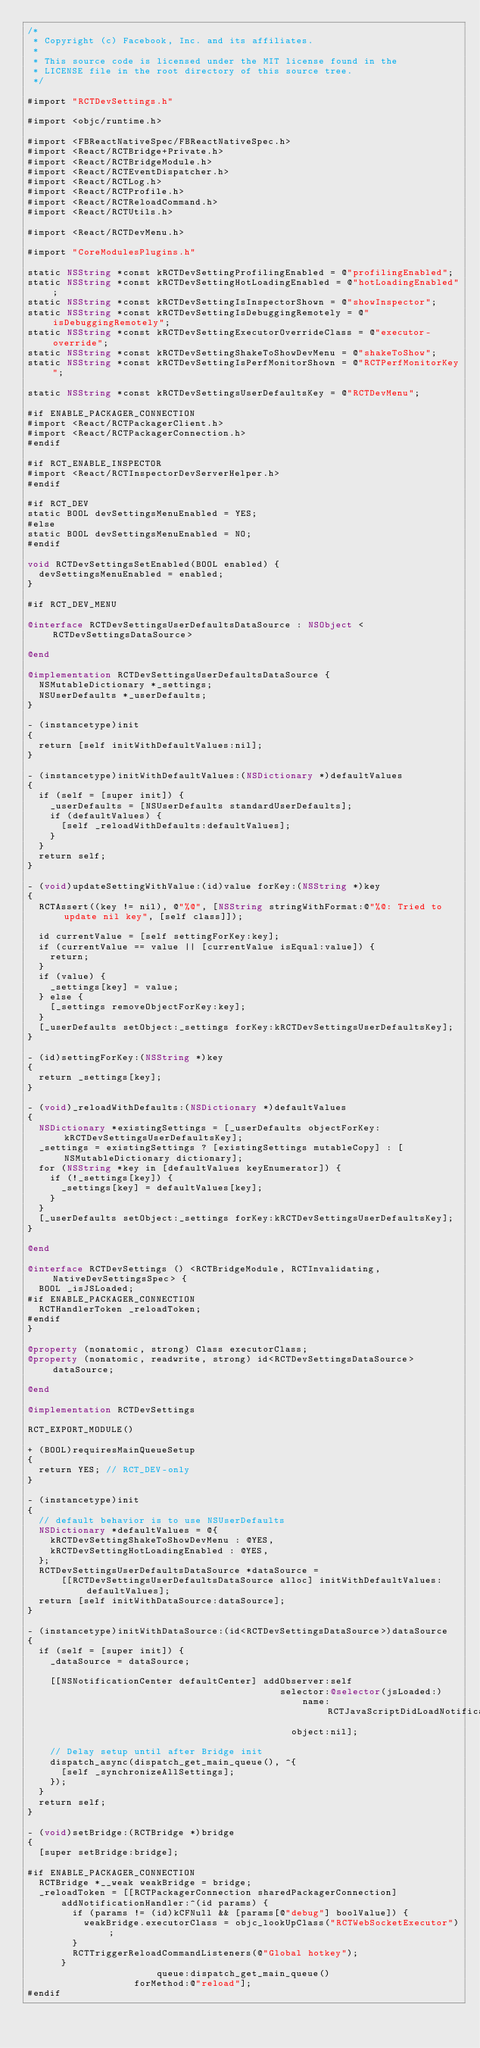<code> <loc_0><loc_0><loc_500><loc_500><_ObjectiveC_>/*
 * Copyright (c) Facebook, Inc. and its affiliates.
 *
 * This source code is licensed under the MIT license found in the
 * LICENSE file in the root directory of this source tree.
 */

#import "RCTDevSettings.h"

#import <objc/runtime.h>

#import <FBReactNativeSpec/FBReactNativeSpec.h>
#import <React/RCTBridge+Private.h>
#import <React/RCTBridgeModule.h>
#import <React/RCTEventDispatcher.h>
#import <React/RCTLog.h>
#import <React/RCTProfile.h>
#import <React/RCTReloadCommand.h>
#import <React/RCTUtils.h>

#import <React/RCTDevMenu.h>

#import "CoreModulesPlugins.h"

static NSString *const kRCTDevSettingProfilingEnabled = @"profilingEnabled";
static NSString *const kRCTDevSettingHotLoadingEnabled = @"hotLoadingEnabled";
static NSString *const kRCTDevSettingIsInspectorShown = @"showInspector";
static NSString *const kRCTDevSettingIsDebuggingRemotely = @"isDebuggingRemotely";
static NSString *const kRCTDevSettingExecutorOverrideClass = @"executor-override";
static NSString *const kRCTDevSettingShakeToShowDevMenu = @"shakeToShow";
static NSString *const kRCTDevSettingIsPerfMonitorShown = @"RCTPerfMonitorKey";

static NSString *const kRCTDevSettingsUserDefaultsKey = @"RCTDevMenu";

#if ENABLE_PACKAGER_CONNECTION
#import <React/RCTPackagerClient.h>
#import <React/RCTPackagerConnection.h>
#endif

#if RCT_ENABLE_INSPECTOR
#import <React/RCTInspectorDevServerHelper.h>
#endif

#if RCT_DEV
static BOOL devSettingsMenuEnabled = YES;
#else
static BOOL devSettingsMenuEnabled = NO;
#endif

void RCTDevSettingsSetEnabled(BOOL enabled) {
  devSettingsMenuEnabled = enabled;
}

#if RCT_DEV_MENU

@interface RCTDevSettingsUserDefaultsDataSource : NSObject <RCTDevSettingsDataSource>

@end

@implementation RCTDevSettingsUserDefaultsDataSource {
  NSMutableDictionary *_settings;
  NSUserDefaults *_userDefaults;
}

- (instancetype)init
{
  return [self initWithDefaultValues:nil];
}

- (instancetype)initWithDefaultValues:(NSDictionary *)defaultValues
{
  if (self = [super init]) {
    _userDefaults = [NSUserDefaults standardUserDefaults];
    if (defaultValues) {
      [self _reloadWithDefaults:defaultValues];
    }
  }
  return self;
}

- (void)updateSettingWithValue:(id)value forKey:(NSString *)key
{
  RCTAssert((key != nil), @"%@", [NSString stringWithFormat:@"%@: Tried to update nil key", [self class]]);

  id currentValue = [self settingForKey:key];
  if (currentValue == value || [currentValue isEqual:value]) {
    return;
  }
  if (value) {
    _settings[key] = value;
  } else {
    [_settings removeObjectForKey:key];
  }
  [_userDefaults setObject:_settings forKey:kRCTDevSettingsUserDefaultsKey];
}

- (id)settingForKey:(NSString *)key
{
  return _settings[key];
}

- (void)_reloadWithDefaults:(NSDictionary *)defaultValues
{
  NSDictionary *existingSettings = [_userDefaults objectForKey:kRCTDevSettingsUserDefaultsKey];
  _settings = existingSettings ? [existingSettings mutableCopy] : [NSMutableDictionary dictionary];
  for (NSString *key in [defaultValues keyEnumerator]) {
    if (!_settings[key]) {
      _settings[key] = defaultValues[key];
    }
  }
  [_userDefaults setObject:_settings forKey:kRCTDevSettingsUserDefaultsKey];
}

@end

@interface RCTDevSettings () <RCTBridgeModule, RCTInvalidating, NativeDevSettingsSpec> {
  BOOL _isJSLoaded;
#if ENABLE_PACKAGER_CONNECTION
  RCTHandlerToken _reloadToken;
#endif
}

@property (nonatomic, strong) Class executorClass;
@property (nonatomic, readwrite, strong) id<RCTDevSettingsDataSource> dataSource;

@end

@implementation RCTDevSettings

RCT_EXPORT_MODULE()

+ (BOOL)requiresMainQueueSetup
{
  return YES; // RCT_DEV-only
}

- (instancetype)init
{
  // default behavior is to use NSUserDefaults
  NSDictionary *defaultValues = @{
    kRCTDevSettingShakeToShowDevMenu : @YES,
    kRCTDevSettingHotLoadingEnabled : @YES,
  };
  RCTDevSettingsUserDefaultsDataSource *dataSource =
      [[RCTDevSettingsUserDefaultsDataSource alloc] initWithDefaultValues:defaultValues];
  return [self initWithDataSource:dataSource];
}

- (instancetype)initWithDataSource:(id<RCTDevSettingsDataSource>)dataSource
{
  if (self = [super init]) {
    _dataSource = dataSource;

    [[NSNotificationCenter defaultCenter] addObserver:self
                                             selector:@selector(jsLoaded:)
                                                 name:RCTJavaScriptDidLoadNotification
                                               object:nil];

    // Delay setup until after Bridge init
    dispatch_async(dispatch_get_main_queue(), ^{
      [self _synchronizeAllSettings];
    });
  }
  return self;
}

- (void)setBridge:(RCTBridge *)bridge
{
  [super setBridge:bridge];

#if ENABLE_PACKAGER_CONNECTION
  RCTBridge *__weak weakBridge = bridge;
  _reloadToken = [[RCTPackagerConnection sharedPackagerConnection]
      addNotificationHandler:^(id params) {
        if (params != (id)kCFNull && [params[@"debug"] boolValue]) {
          weakBridge.executorClass = objc_lookUpClass("RCTWebSocketExecutor");
        }
        RCTTriggerReloadCommandListeners(@"Global hotkey");
      }
                       queue:dispatch_get_main_queue()
                   forMethod:@"reload"];
#endif
</code> 